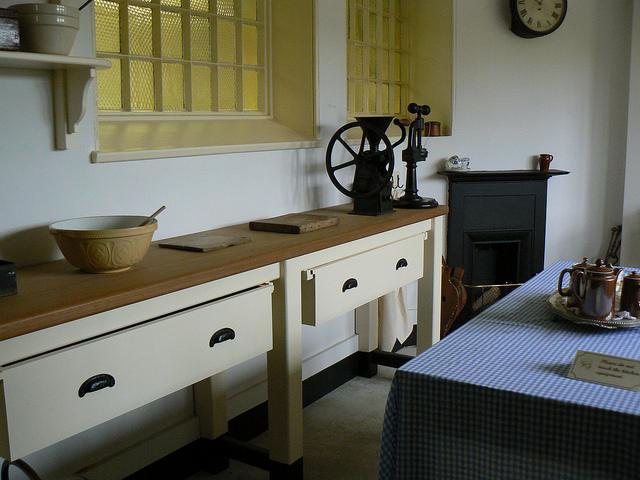How many bowls are there?
Give a very brief answer. 2. 